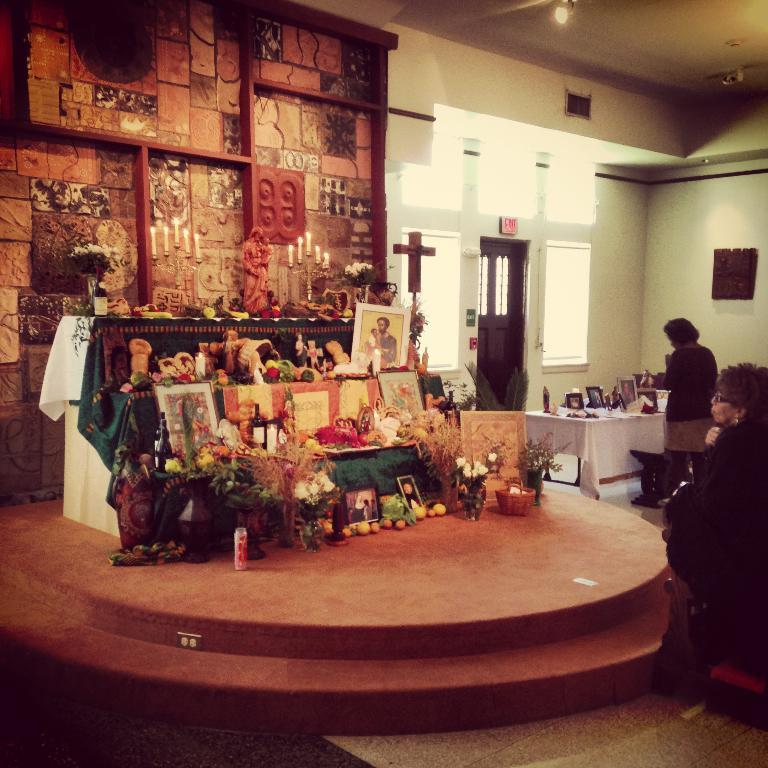What is the color of the wall in the image? The wall in the image is white. What can be seen on the wall in the image? There is a window in the image. What objects are present on the window sill in the image? There are candles in the image. What type of decorative items are present on the wall in the image? There are photo frames in the image. How many people are visible in the image? There are two people in the image. What type of brass instrument is being played by one of the people in the image? There is no brass instrument or any indication of musical activity in the image. The image only shows a white wall, a window, candles, photo frames, and two people. 